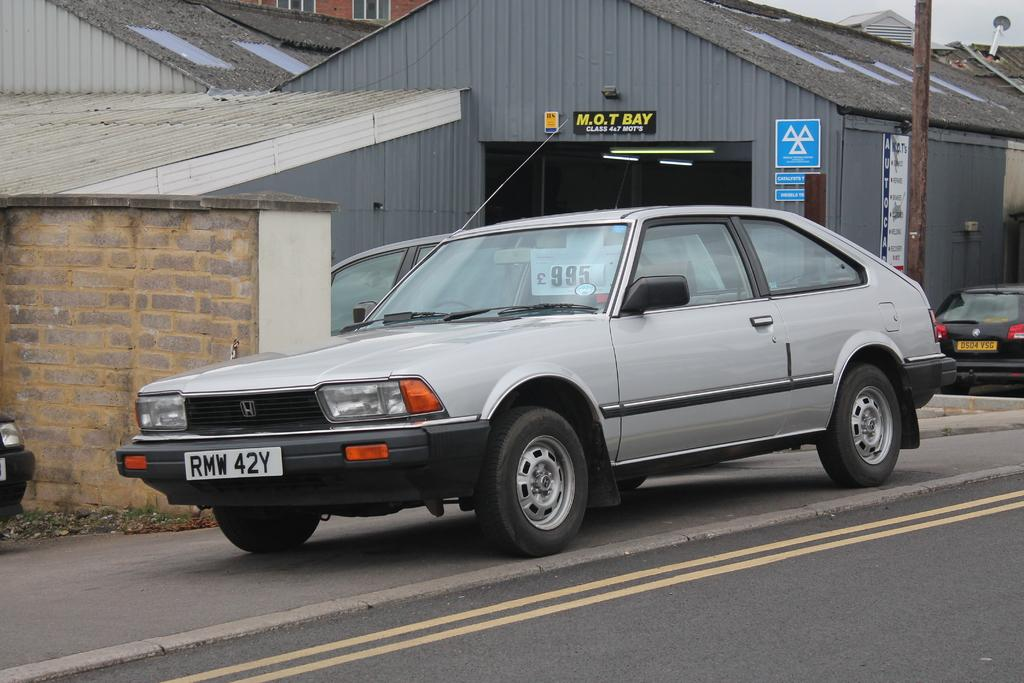What type of structure can be seen in the background of the image? There is a shed in the background of the image. What other elements can be seen in the background of the image? There are boards, a rooftop, a wall, windows, a pole, and lights visible in the background of the image. What is the main subject of the image? There are vehicles in the image. What type of surface is present in the image? There is a road in the image. What time of day is it in the image, and what type of stew is being prepared? The time of day cannot be determined from the image, and there is no mention of stew being prepared. 